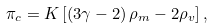Convert formula to latex. <formula><loc_0><loc_0><loc_500><loc_500>\pi _ { c } = K \left [ \left ( 3 \gamma - 2 \right ) \rho _ { m } - 2 \rho _ { v } \right ] ,</formula> 